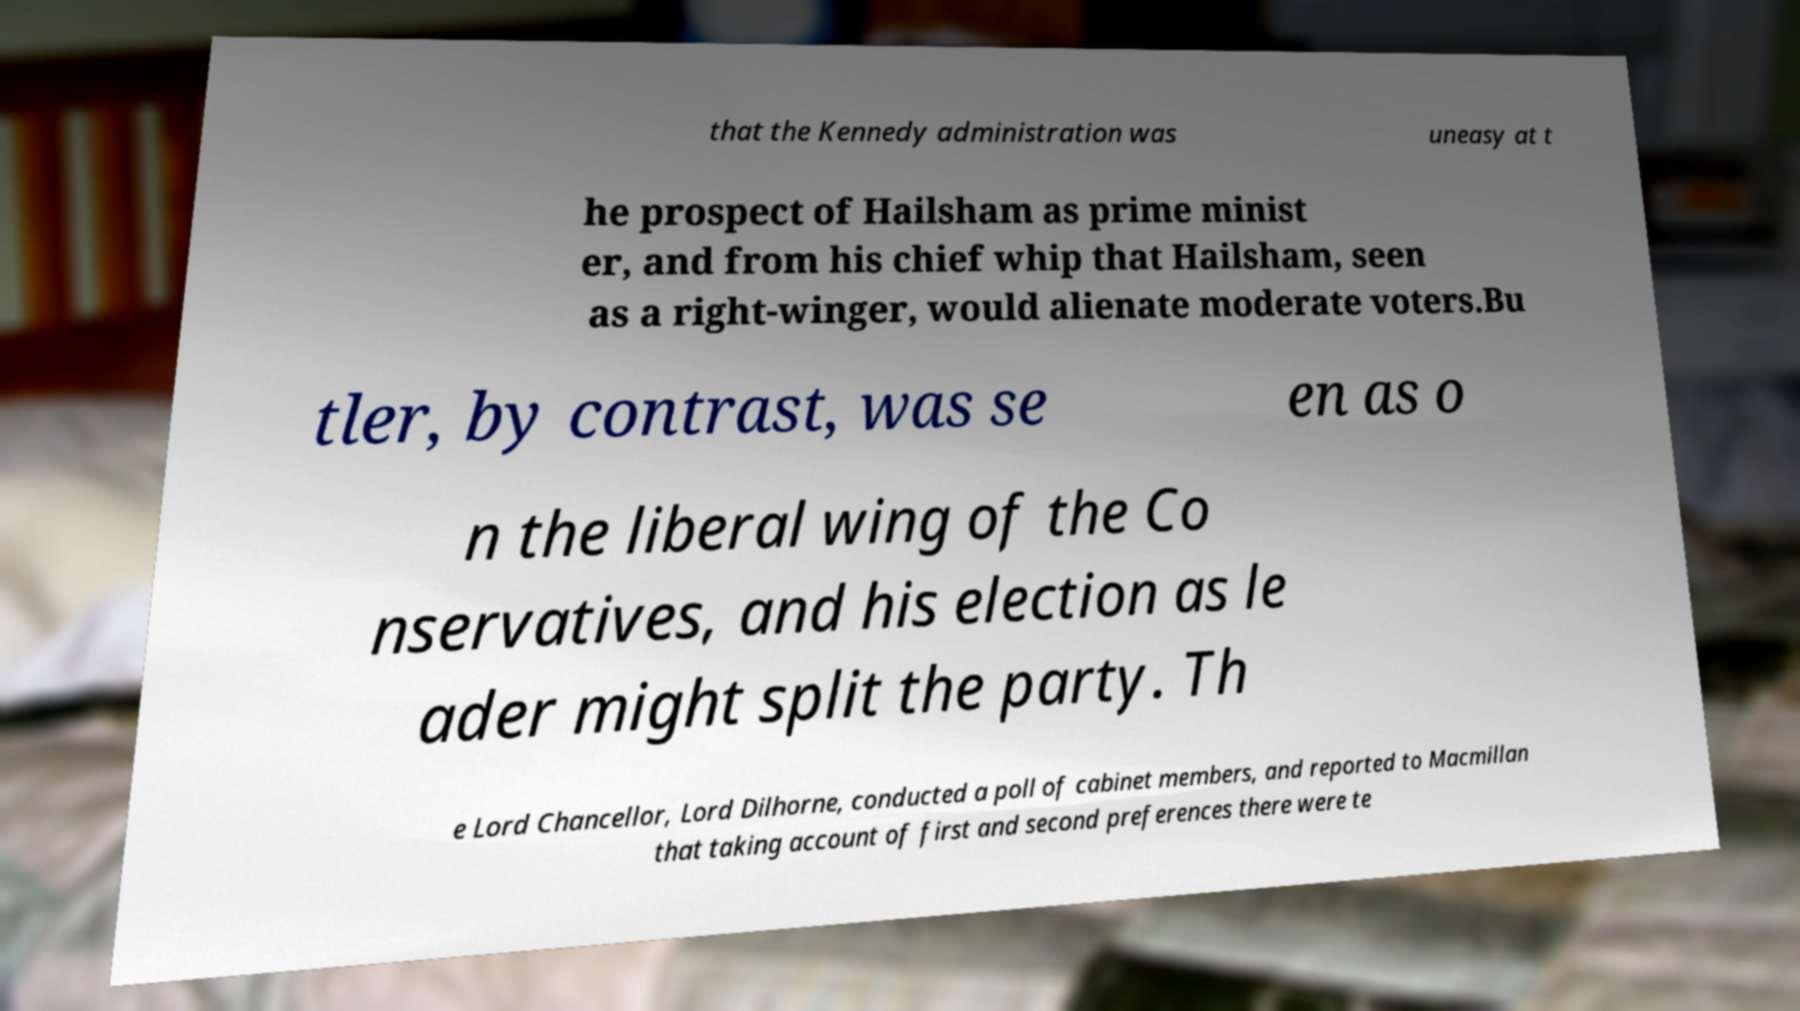Could you assist in decoding the text presented in this image and type it out clearly? that the Kennedy administration was uneasy at t he prospect of Hailsham as prime minist er, and from his chief whip that Hailsham, seen as a right-winger, would alienate moderate voters.Bu tler, by contrast, was se en as o n the liberal wing of the Co nservatives, and his election as le ader might split the party. Th e Lord Chancellor, Lord Dilhorne, conducted a poll of cabinet members, and reported to Macmillan that taking account of first and second preferences there were te 